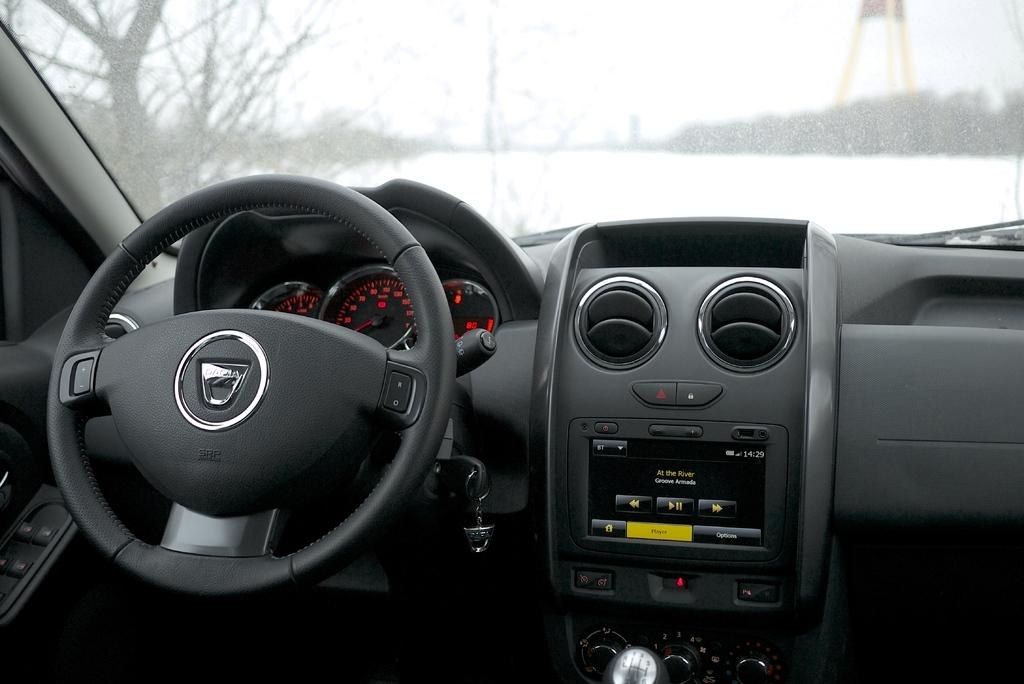What type of setting is depicted in the image? The image shows the inside view of a vehicle. What can be seen in the background of the image? There are trees and the sky visible in the background of the image. How many snakes are crawling on the paper in the image? There is no paper or snake present in the image; it shows the inside view of a vehicle with trees and the sky in the background. 